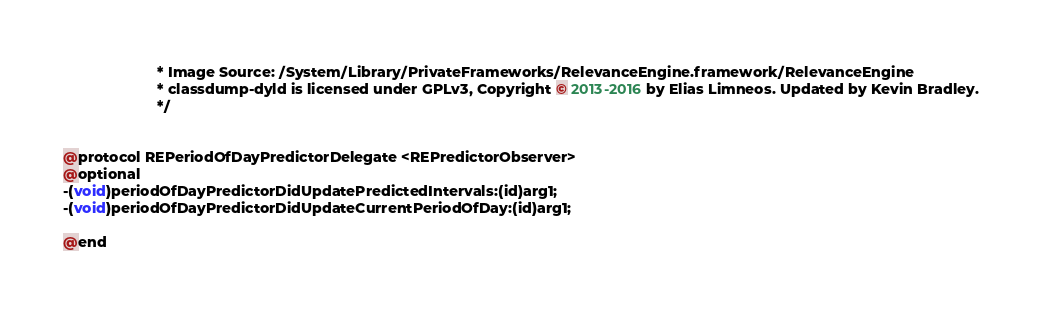Convert code to text. <code><loc_0><loc_0><loc_500><loc_500><_C_>                       * Image Source: /System/Library/PrivateFrameworks/RelevanceEngine.framework/RelevanceEngine
                       * classdump-dyld is licensed under GPLv3, Copyright © 2013-2016 by Elias Limneos. Updated by Kevin Bradley.
                       */


@protocol REPeriodOfDayPredictorDelegate <REPredictorObserver>
@optional
-(void)periodOfDayPredictorDidUpdatePredictedIntervals:(id)arg1;
-(void)periodOfDayPredictorDidUpdateCurrentPeriodOfDay:(id)arg1;

@end

</code> 